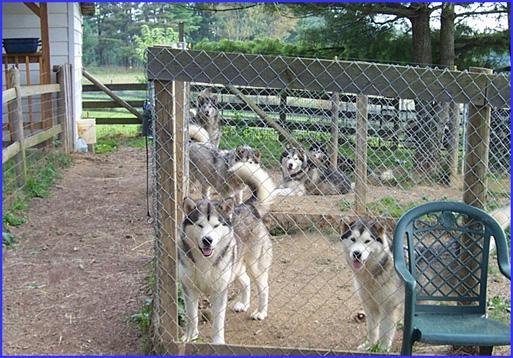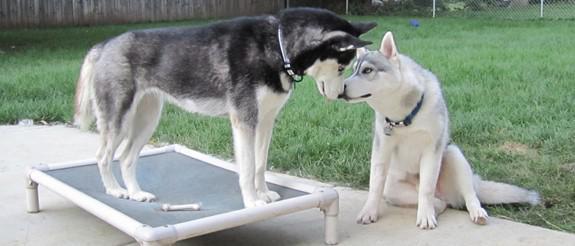The first image is the image on the left, the second image is the image on the right. Examine the images to the left and right. Is the description "One image shows at least one dog in a wire-covered kennel, and the other image shows a dog with 'salt and pepper' coloring on the left of a paler dog." accurate? Answer yes or no. Yes. The first image is the image on the left, the second image is the image on the right. Evaluate the accuracy of this statement regarding the images: "At least one dog is standing on grass.". Is it true? Answer yes or no. No. 